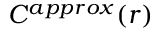Convert formula to latex. <formula><loc_0><loc_0><loc_500><loc_500>C ^ { a p p r o x } ( r )</formula> 